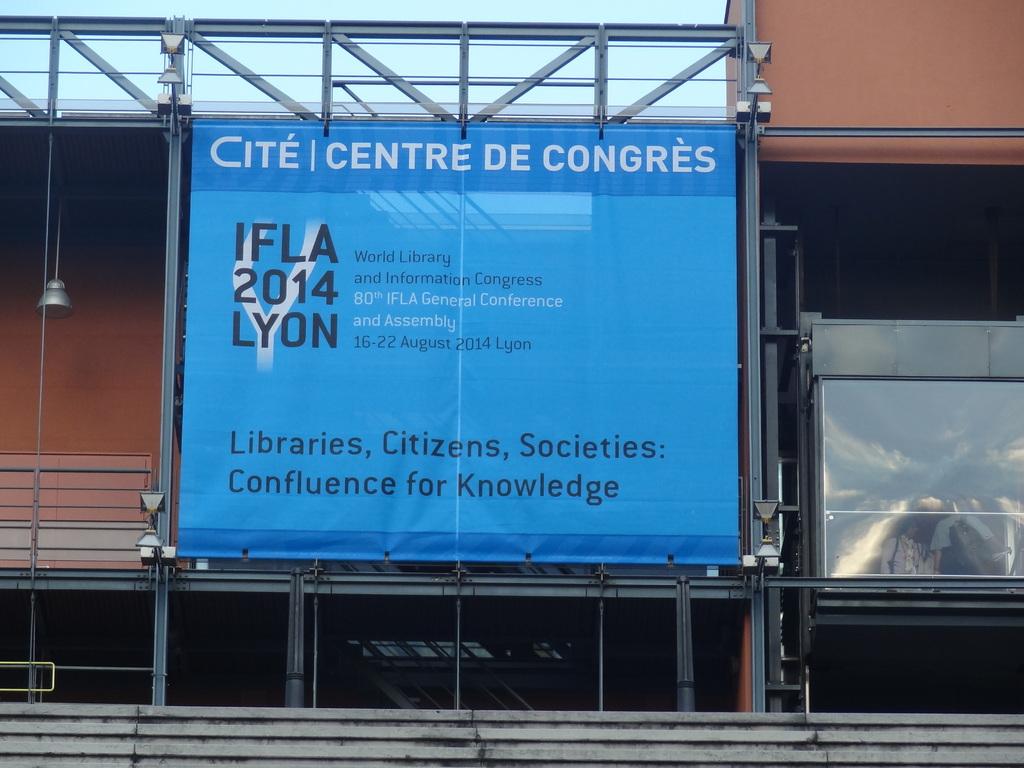What year does this sign advertise?
Provide a short and direct response. 2014. What does the sign say at the top?
Keep it short and to the point. Cite centre de congres. 